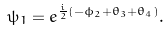<formula> <loc_0><loc_0><loc_500><loc_500>\psi _ { 1 } = e ^ { \frac { i } { 2 } ( - \phi _ { 2 } + \theta _ { 3 } + \theta _ { 4 } ) } .</formula> 